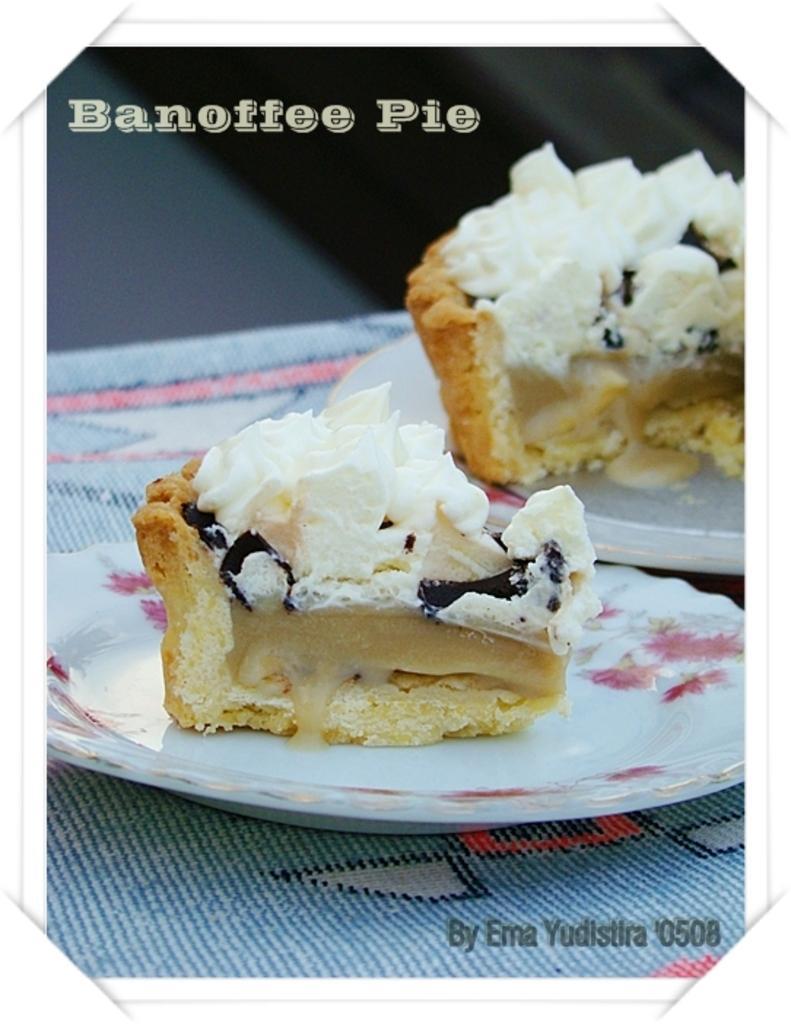Please provide a concise description of this image. In this given picture, We can see a mat and top of that, We can see two plates including two cake pieces. 